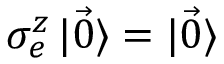Convert formula to latex. <formula><loc_0><loc_0><loc_500><loc_500>\sigma _ { e } ^ { z } \ m a t h i n n e r { | { \vec { 0 } } \rangle } = \ m a t h i n n e r { | { \vec { 0 } } \rangle }</formula> 